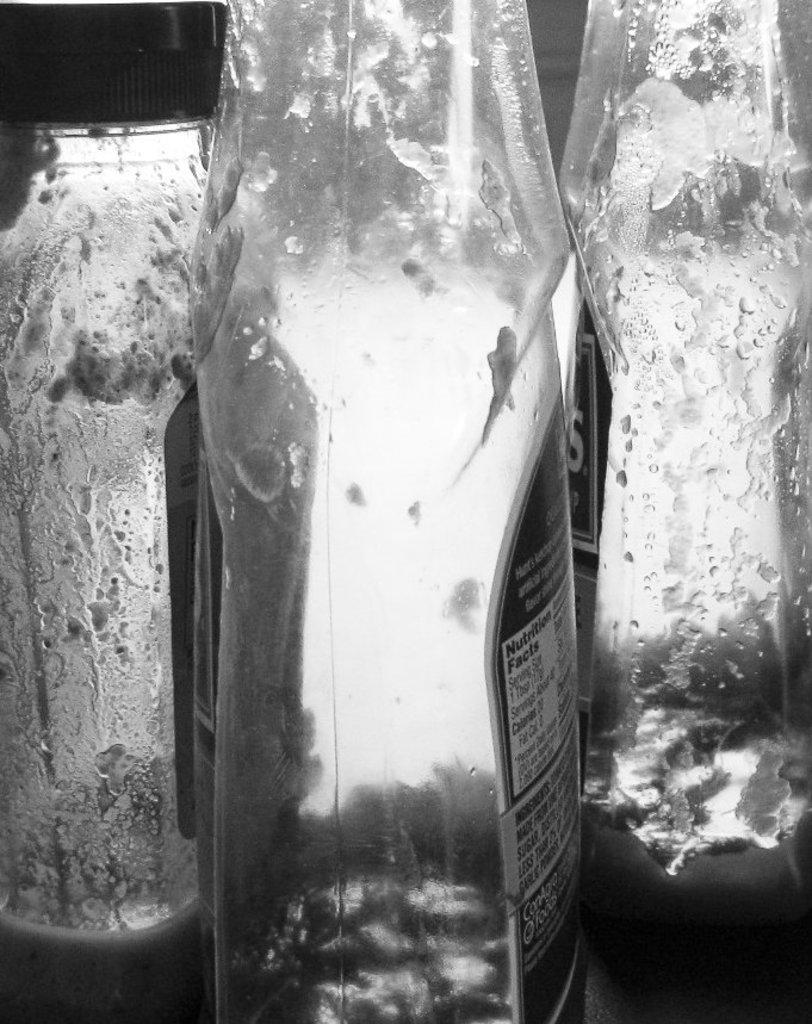Can you describe this image briefly? In this image there are three bottles in black and white. All the bottles are empty. Each of the bottle are labelled and some text printed on those labels. 